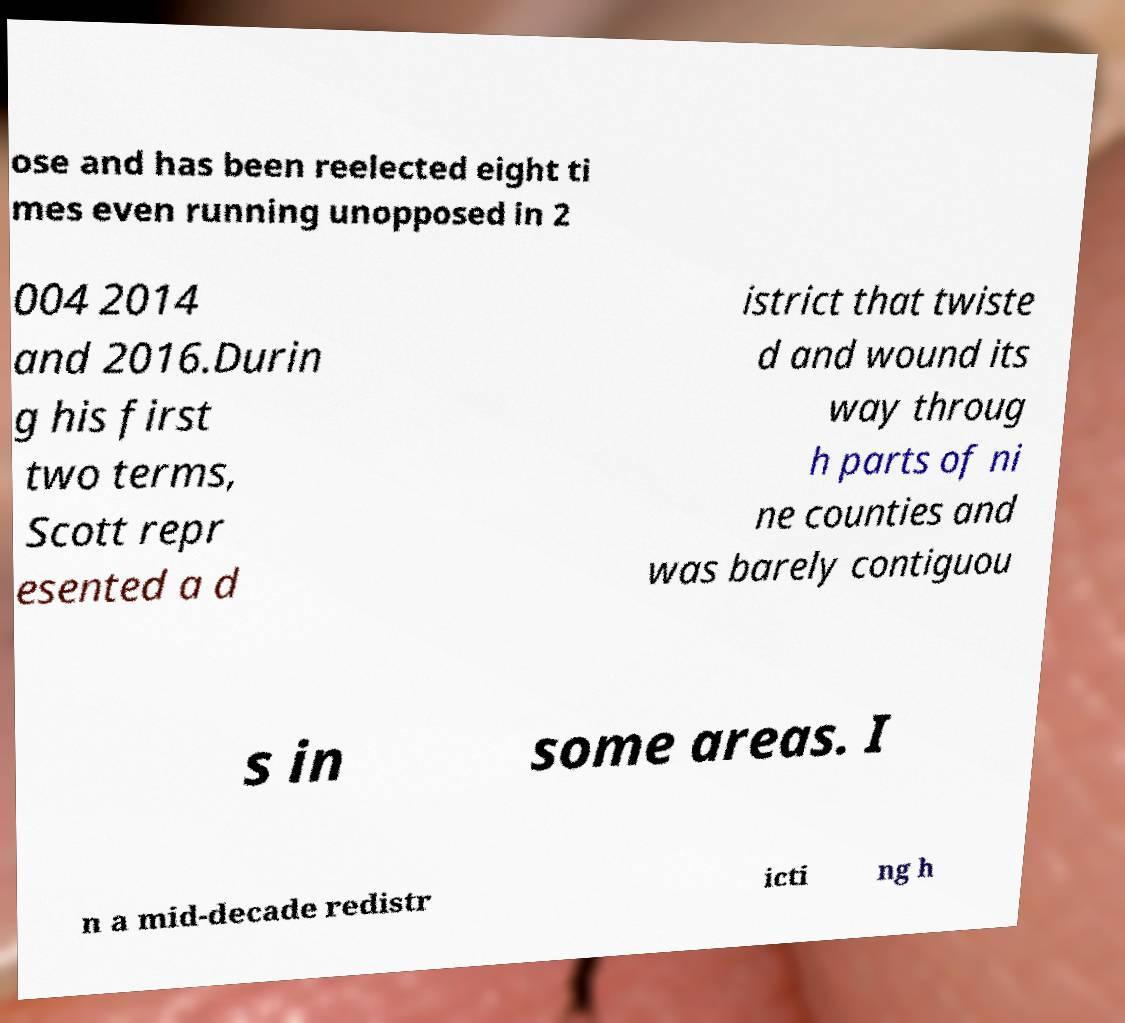For documentation purposes, I need the text within this image transcribed. Could you provide that? ose and has been reelected eight ti mes even running unopposed in 2 004 2014 and 2016.Durin g his first two terms, Scott repr esented a d istrict that twiste d and wound its way throug h parts of ni ne counties and was barely contiguou s in some areas. I n a mid-decade redistr icti ng h 